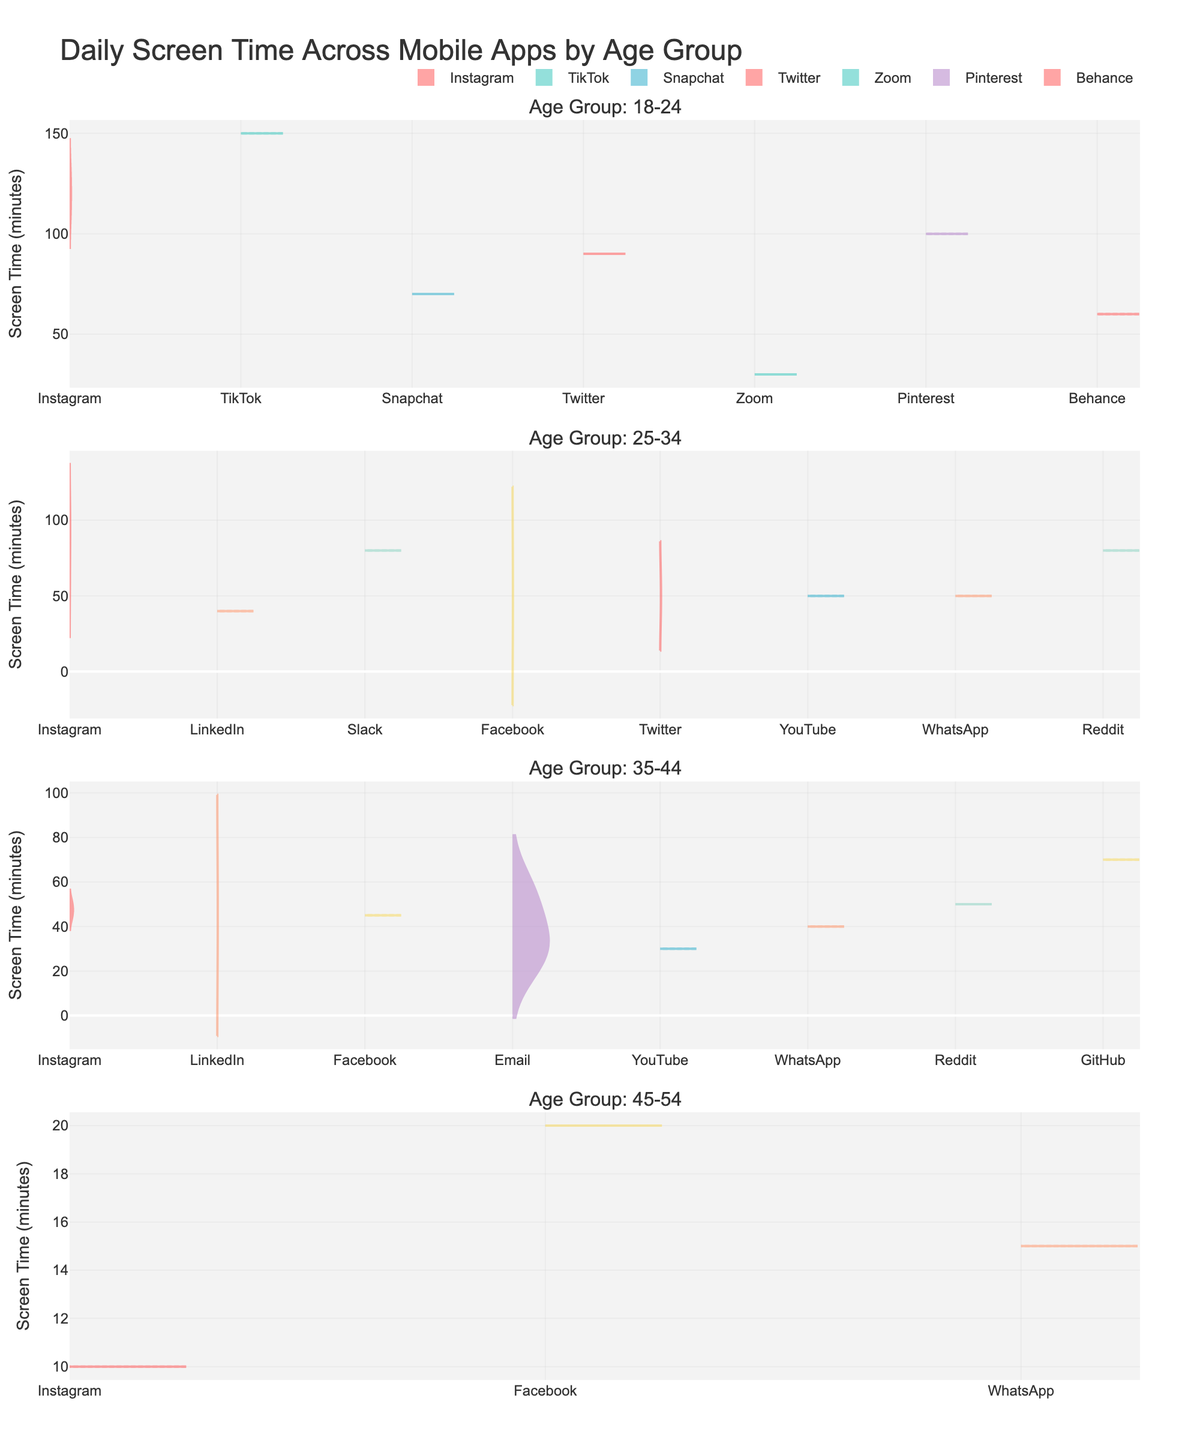What is the title of the figure? The title of the figure is usually placed at the top center of the plot. For this plot, it is specific to the topic of daily screen time distribution across mobile apps segmented by different age groups.
Answer: "Daily Screen Time Across Mobile Apps by Age Group" Which age group has the widest range of screen time usage for Instagram? The range of screen time usage for Instagram can be observed by the spread of the violin plot for Instagram within each age group subplot. The wider the spread, the wider the range of usage.
Answer: 18-24 For the age group 25-34, which app has the highest average screen time? By examining the mean lines in the violin plots for each app within the 25-34 age group subplot, we can identify which app's mean line is positioned the highest.
Answer: Instagram How does screen time for Facebook differ between age groups 18-24 and 35-44? The violin plots for Facebook in the age groups 18-24 and 35-44 should be compared by looking at their respective shapes, medians, and spreads. This comparison will show the differences in screen time distributions.
Answer: More varied in 35-44, less in 18-24 Which age group shows the least variability in screen time for LinkedIn? Variability in screen time usage can be assessed by looking at the spread of the violin plots for LinkedIn within each age group subplot, where a narrower plot indicates less variability.
Answer: 25-34 Which app is most frequently used by students in the 18-24 age group? For the age group 18-24, we should look at the density of the violin plots for each app used by students. The app with the thickest (densest) plot indicates the highest frequency of usage.
Answer: TikTok How does daily screen time for software engineers on Slack compare to students on Instagram in the 25-34 age group? To answer this, we need to compare the violin plot heights and mean lines for Slack usage by software engineers and Instagram usage by students in the 25-34 age group within the corresponding subplot.
Answer: Similar, but Instagram higher What can be inferred about the usage of Email among different age groups? We can infer the overall usage trends for Email by observing the thickness, spread, and mean lines of the violin plots for Email across all age groups. This can reveal variations in screen time among different age groups.
Answer: Usage decreases with age Which occupation has the highest median screen time for Instagram in the 18-24 age group? The median screen time for Instagram can be observed in the violin plot for each occupation within the 18-24 age group. The median is the line in the center of the violin plot that divides the data into two equal parts.
Answer: Graphic Designer 